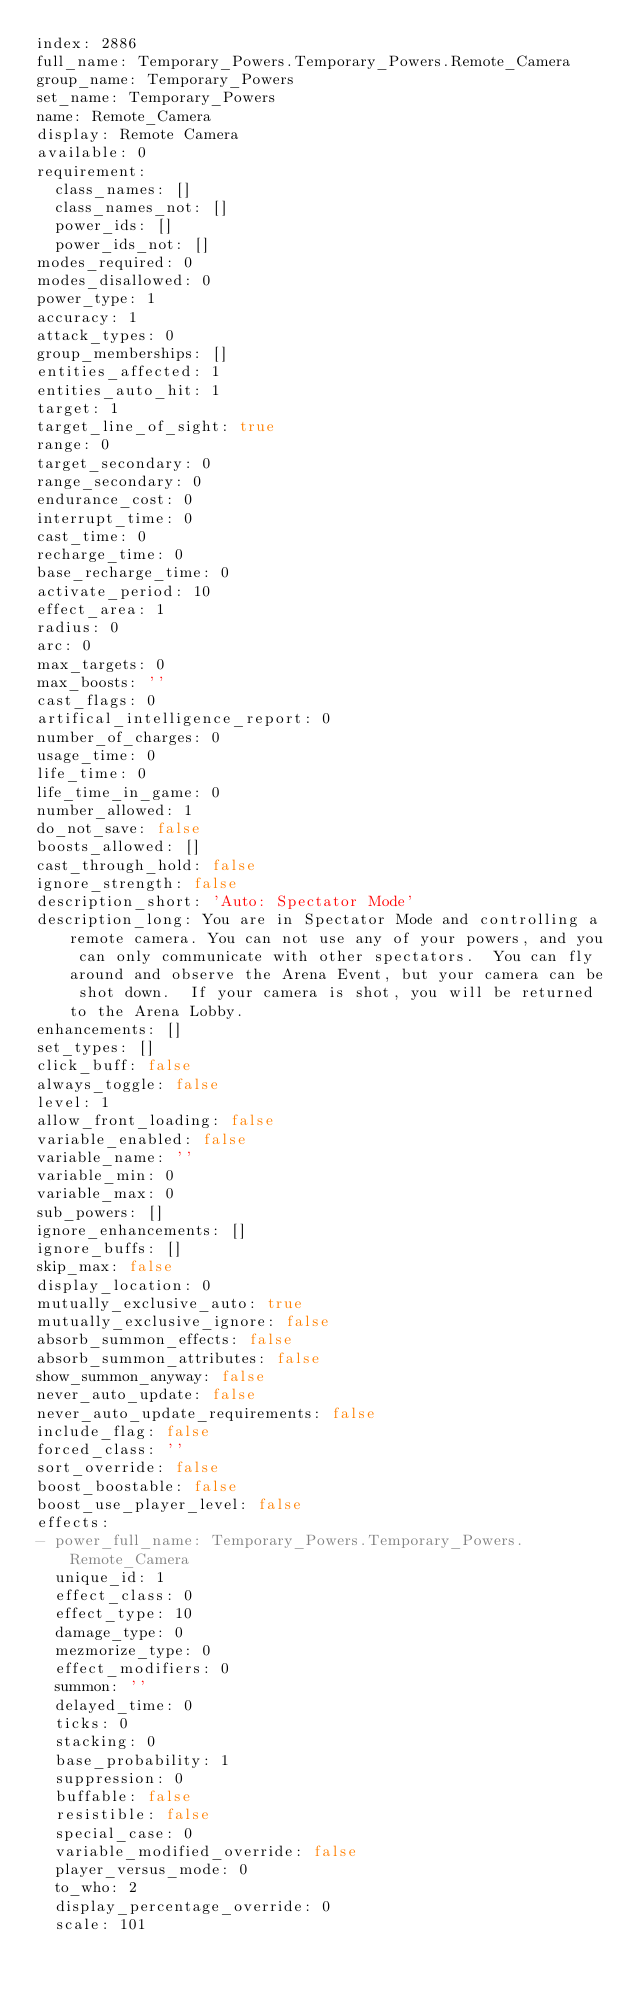<code> <loc_0><loc_0><loc_500><loc_500><_YAML_>index: 2886
full_name: Temporary_Powers.Temporary_Powers.Remote_Camera
group_name: Temporary_Powers
set_name: Temporary_Powers
name: Remote_Camera
display: Remote Camera
available: 0
requirement:
  class_names: []
  class_names_not: []
  power_ids: []
  power_ids_not: []
modes_required: 0
modes_disallowed: 0
power_type: 1
accuracy: 1
attack_types: 0
group_memberships: []
entities_affected: 1
entities_auto_hit: 1
target: 1
target_line_of_sight: true
range: 0
target_secondary: 0
range_secondary: 0
endurance_cost: 0
interrupt_time: 0
cast_time: 0
recharge_time: 0
base_recharge_time: 0
activate_period: 10
effect_area: 1
radius: 0
arc: 0
max_targets: 0
max_boosts: ''
cast_flags: 0
artifical_intelligence_report: 0
number_of_charges: 0
usage_time: 0
life_time: 0
life_time_in_game: 0
number_allowed: 1
do_not_save: false
boosts_allowed: []
cast_through_hold: false
ignore_strength: false
description_short: 'Auto: Spectator Mode'
description_long: You are in Spectator Mode and controlling a remote camera. You can not use any of your powers, and you can only communicate with other spectators.  You can fly around and observe the Arena Event, but your camera can be shot down.  If your camera is shot, you will be returned to the Arena Lobby.
enhancements: []
set_types: []
click_buff: false
always_toggle: false
level: 1
allow_front_loading: false
variable_enabled: false
variable_name: ''
variable_min: 0
variable_max: 0
sub_powers: []
ignore_enhancements: []
ignore_buffs: []
skip_max: false
display_location: 0
mutually_exclusive_auto: true
mutually_exclusive_ignore: false
absorb_summon_effects: false
absorb_summon_attributes: false
show_summon_anyway: false
never_auto_update: false
never_auto_update_requirements: false
include_flag: false
forced_class: ''
sort_override: false
boost_boostable: false
boost_use_player_level: false
effects:
- power_full_name: Temporary_Powers.Temporary_Powers.Remote_Camera
  unique_id: 1
  effect_class: 0
  effect_type: 10
  damage_type: 0
  mezmorize_type: 0
  effect_modifiers: 0
  summon: ''
  delayed_time: 0
  ticks: 0
  stacking: 0
  base_probability: 1
  suppression: 0
  buffable: false
  resistible: false
  special_case: 0
  variable_modified_override: false
  player_versus_mode: 0
  to_who: 2
  display_percentage_override: 0
  scale: 101</code> 